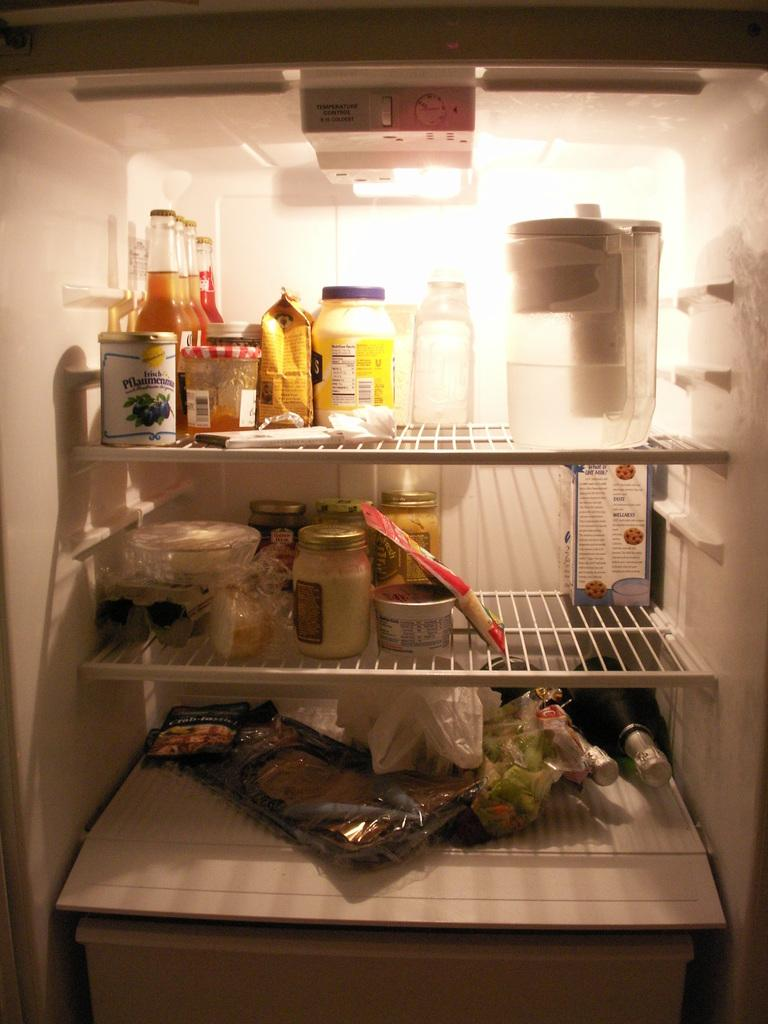Where is the image taken? The image is inside a fridge. What can be seen inside the fridge? There are racks, a box, and various items such as bottles, packets, and other items on the racks. Is there a light source inside the fridge? Yes, there is a light in the fridge. What is the purpose of the button at the top of the fridge? The button at the top of the fridge is likely used to control the fridge's settings or functions. Can you see the fridge taking flight in the image? No, the fridge is not taking flight in the image; it is stationary inside a room or kitchen. 